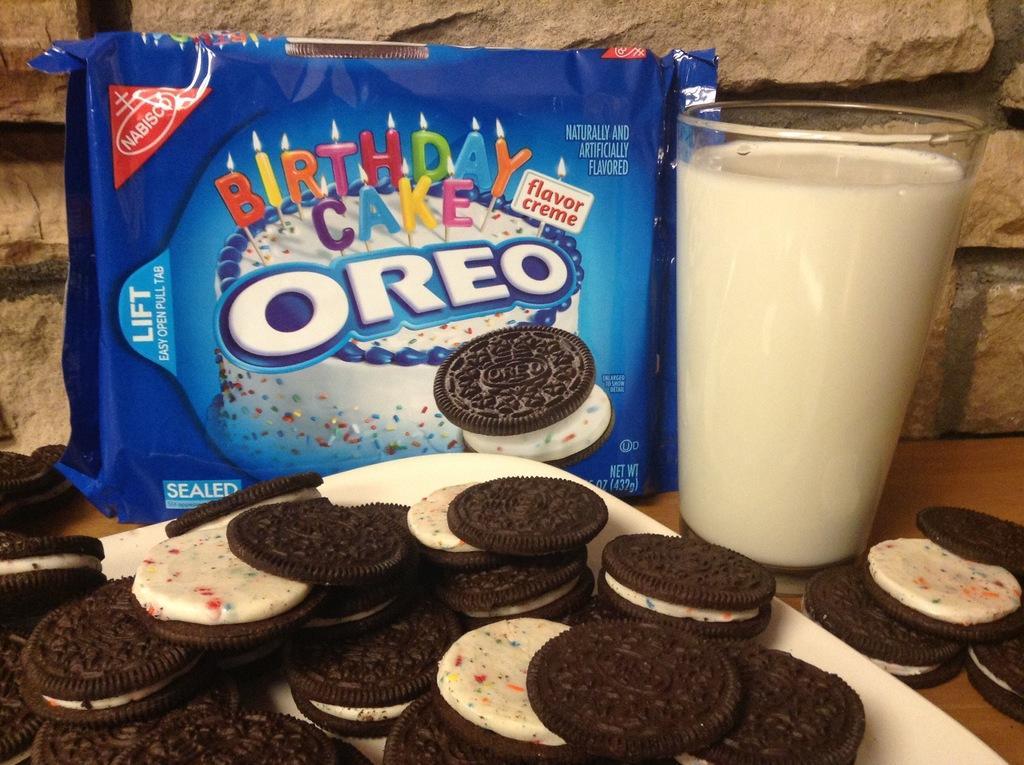How would you summarize this image in a sentence or two? This image is taken indoors. In the background there is a wall. In the middle of the image there is a with a glass of milk, a few biscuits, a tray with a few biscuits and a biscuit packet on it. 